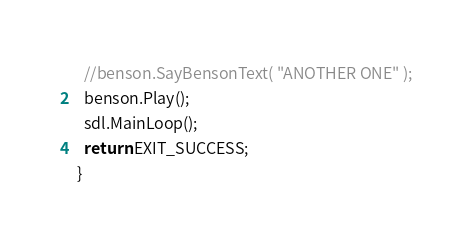Convert code to text. <code><loc_0><loc_0><loc_500><loc_500><_C++_>  //benson.SayBensonText( "ANOTHER ONE" );
  benson.Play();
  sdl.MainLoop();
  return EXIT_SUCCESS;
}
</code> 